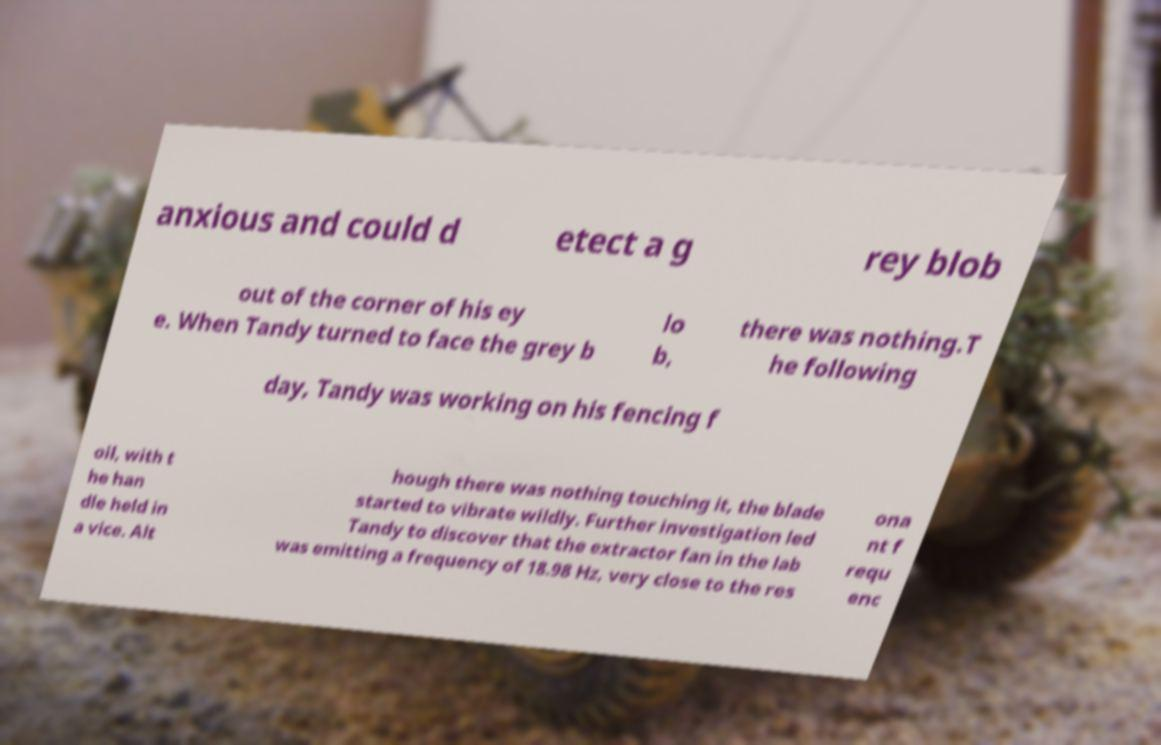Please identify and transcribe the text found in this image. anxious and could d etect a g rey blob out of the corner of his ey e. When Tandy turned to face the grey b lo b, there was nothing.T he following day, Tandy was working on his fencing f oil, with t he han dle held in a vice. Alt hough there was nothing touching it, the blade started to vibrate wildly. Further investigation led Tandy to discover that the extractor fan in the lab was emitting a frequency of 18.98 Hz, very close to the res ona nt f requ enc 